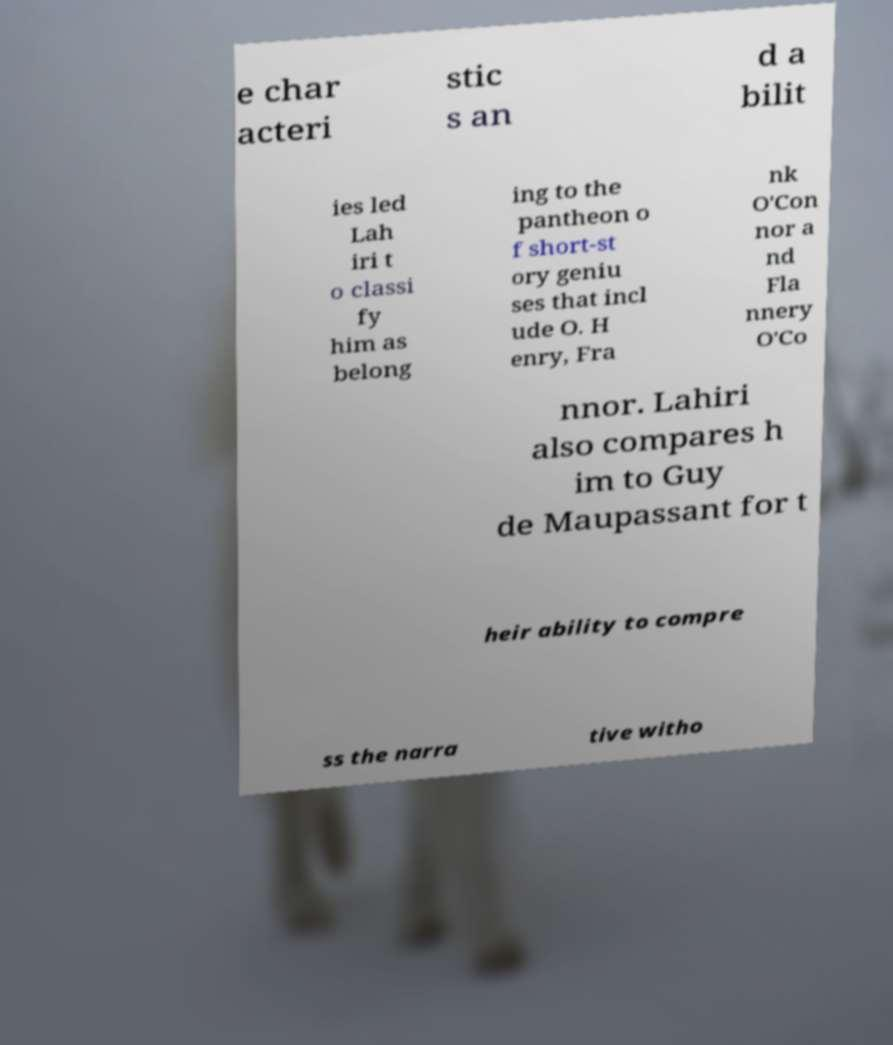For documentation purposes, I need the text within this image transcribed. Could you provide that? e char acteri stic s an d a bilit ies led Lah iri t o classi fy him as belong ing to the pantheon o f short-st ory geniu ses that incl ude O. H enry, Fra nk O'Con nor a nd Fla nnery O'Co nnor. Lahiri also compares h im to Guy de Maupassant for t heir ability to compre ss the narra tive witho 